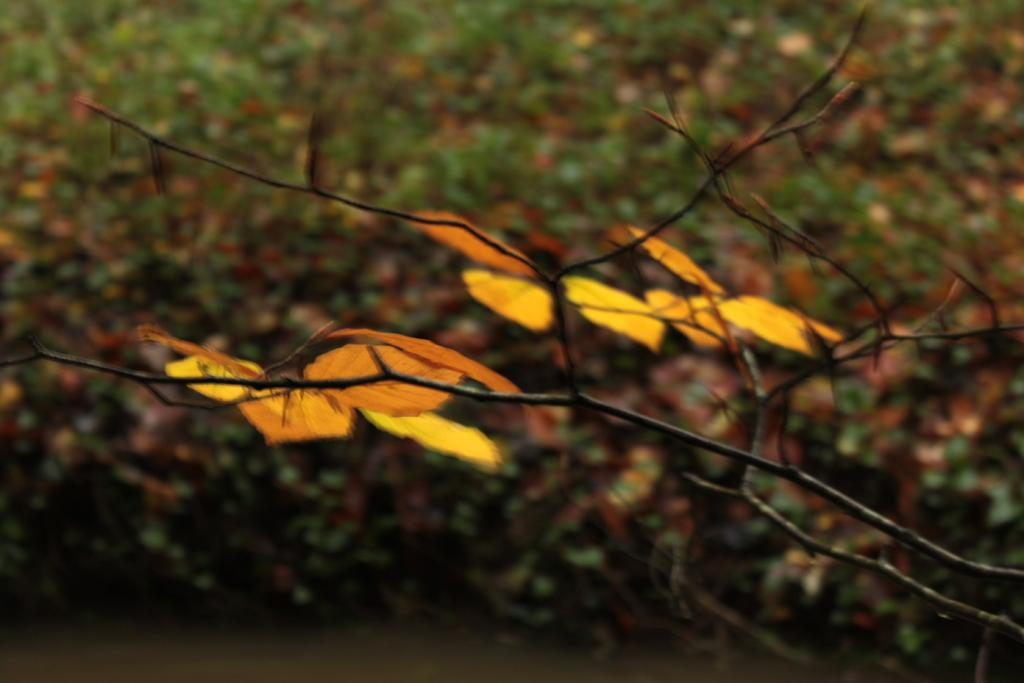What type of living organisms can be seen in the image? Plants can be seen in the image. What can be seen in the middle of the image? There is a branch in the middle of the image. What type of chess piece is located on the branch in the image? There is no chess piece present on the branch in the image. How quiet is the environment in the image? The provided facts do not give any information about the noise level or environment in the image. 